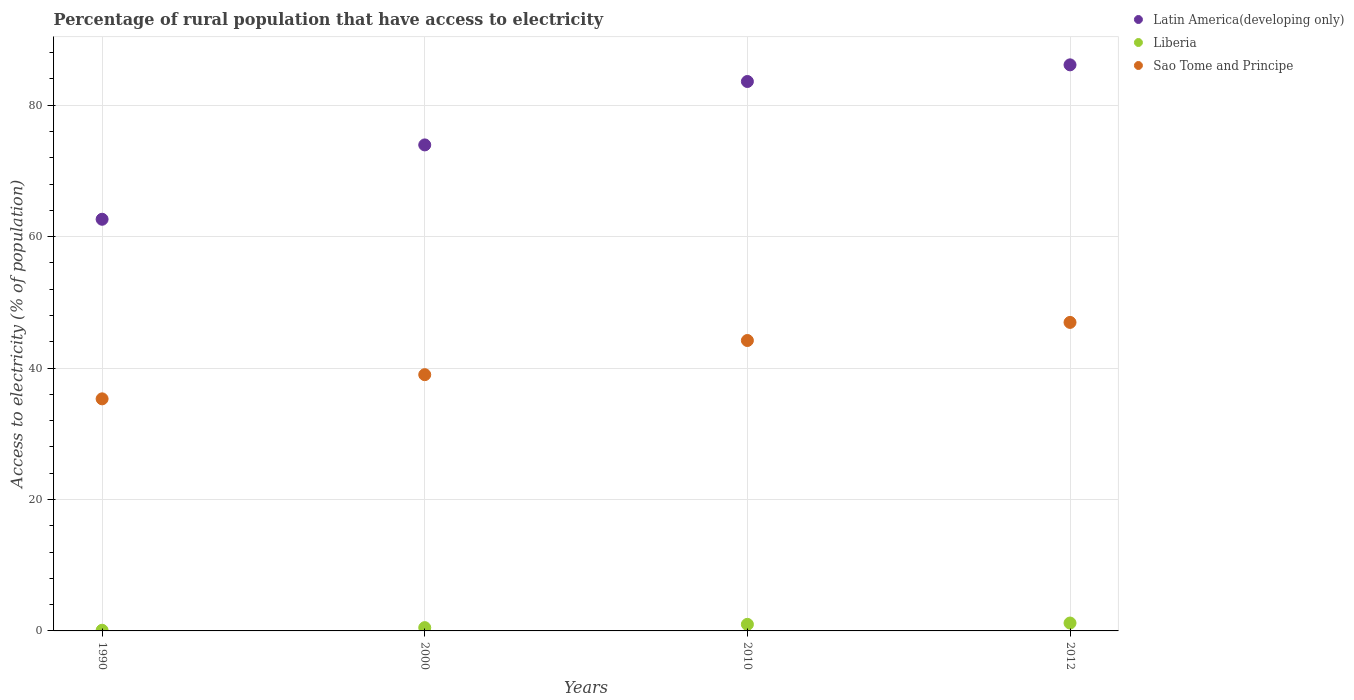How many different coloured dotlines are there?
Your response must be concise. 3. Is the number of dotlines equal to the number of legend labels?
Ensure brevity in your answer.  Yes. What is the percentage of rural population that have access to electricity in Sao Tome and Principe in 2000?
Keep it short and to the point. 39. Across all years, what is the maximum percentage of rural population that have access to electricity in Liberia?
Your response must be concise. 1.2. Across all years, what is the minimum percentage of rural population that have access to electricity in Latin America(developing only)?
Provide a succinct answer. 62.65. In which year was the percentage of rural population that have access to electricity in Sao Tome and Principe maximum?
Offer a very short reply. 2012. In which year was the percentage of rural population that have access to electricity in Liberia minimum?
Ensure brevity in your answer.  1990. What is the total percentage of rural population that have access to electricity in Sao Tome and Principe in the graph?
Ensure brevity in your answer.  165.47. What is the difference between the percentage of rural population that have access to electricity in Liberia in 2012 and the percentage of rural population that have access to electricity in Sao Tome and Principe in 2010?
Your answer should be compact. -43. What is the average percentage of rural population that have access to electricity in Latin America(developing only) per year?
Keep it short and to the point. 76.6. In the year 1990, what is the difference between the percentage of rural population that have access to electricity in Latin America(developing only) and percentage of rural population that have access to electricity in Liberia?
Offer a terse response. 62.55. What is the ratio of the percentage of rural population that have access to electricity in Latin America(developing only) in 1990 to that in 2000?
Ensure brevity in your answer.  0.85. Is the difference between the percentage of rural population that have access to electricity in Latin America(developing only) in 1990 and 2010 greater than the difference between the percentage of rural population that have access to electricity in Liberia in 1990 and 2010?
Make the answer very short. No. What is the difference between the highest and the second highest percentage of rural population that have access to electricity in Sao Tome and Principe?
Give a very brief answer. 2.75. What is the difference between the highest and the lowest percentage of rural population that have access to electricity in Latin America(developing only)?
Give a very brief answer. 23.5. In how many years, is the percentage of rural population that have access to electricity in Liberia greater than the average percentage of rural population that have access to electricity in Liberia taken over all years?
Offer a terse response. 2. Is the sum of the percentage of rural population that have access to electricity in Sao Tome and Principe in 1990 and 2012 greater than the maximum percentage of rural population that have access to electricity in Latin America(developing only) across all years?
Make the answer very short. No. Is it the case that in every year, the sum of the percentage of rural population that have access to electricity in Sao Tome and Principe and percentage of rural population that have access to electricity in Liberia  is greater than the percentage of rural population that have access to electricity in Latin America(developing only)?
Offer a very short reply. No. How many dotlines are there?
Your answer should be very brief. 3. What is the difference between two consecutive major ticks on the Y-axis?
Ensure brevity in your answer.  20. Does the graph contain any zero values?
Keep it short and to the point. No. How many legend labels are there?
Your response must be concise. 3. What is the title of the graph?
Make the answer very short. Percentage of rural population that have access to electricity. What is the label or title of the Y-axis?
Offer a terse response. Access to electricity (% of population). What is the Access to electricity (% of population) of Latin America(developing only) in 1990?
Offer a terse response. 62.65. What is the Access to electricity (% of population) of Sao Tome and Principe in 1990?
Offer a terse response. 35.32. What is the Access to electricity (% of population) of Latin America(developing only) in 2000?
Give a very brief answer. 73.97. What is the Access to electricity (% of population) of Latin America(developing only) in 2010?
Provide a succinct answer. 83.62. What is the Access to electricity (% of population) in Sao Tome and Principe in 2010?
Your answer should be very brief. 44.2. What is the Access to electricity (% of population) in Latin America(developing only) in 2012?
Make the answer very short. 86.15. What is the Access to electricity (% of population) of Sao Tome and Principe in 2012?
Provide a short and direct response. 46.95. Across all years, what is the maximum Access to electricity (% of population) in Latin America(developing only)?
Provide a short and direct response. 86.15. Across all years, what is the maximum Access to electricity (% of population) in Sao Tome and Principe?
Your answer should be compact. 46.95. Across all years, what is the minimum Access to electricity (% of population) in Latin America(developing only)?
Your answer should be very brief. 62.65. Across all years, what is the minimum Access to electricity (% of population) in Liberia?
Make the answer very short. 0.1. Across all years, what is the minimum Access to electricity (% of population) in Sao Tome and Principe?
Your response must be concise. 35.32. What is the total Access to electricity (% of population) in Latin America(developing only) in the graph?
Offer a terse response. 306.39. What is the total Access to electricity (% of population) of Liberia in the graph?
Offer a terse response. 2.8. What is the total Access to electricity (% of population) in Sao Tome and Principe in the graph?
Your answer should be very brief. 165.47. What is the difference between the Access to electricity (% of population) in Latin America(developing only) in 1990 and that in 2000?
Give a very brief answer. -11.32. What is the difference between the Access to electricity (% of population) in Liberia in 1990 and that in 2000?
Ensure brevity in your answer.  -0.4. What is the difference between the Access to electricity (% of population) of Sao Tome and Principe in 1990 and that in 2000?
Your answer should be very brief. -3.68. What is the difference between the Access to electricity (% of population) in Latin America(developing only) in 1990 and that in 2010?
Offer a terse response. -20.97. What is the difference between the Access to electricity (% of population) in Liberia in 1990 and that in 2010?
Make the answer very short. -0.9. What is the difference between the Access to electricity (% of population) of Sao Tome and Principe in 1990 and that in 2010?
Offer a very short reply. -8.88. What is the difference between the Access to electricity (% of population) in Latin America(developing only) in 1990 and that in 2012?
Give a very brief answer. -23.5. What is the difference between the Access to electricity (% of population) in Sao Tome and Principe in 1990 and that in 2012?
Give a very brief answer. -11.63. What is the difference between the Access to electricity (% of population) in Latin America(developing only) in 2000 and that in 2010?
Give a very brief answer. -9.65. What is the difference between the Access to electricity (% of population) in Liberia in 2000 and that in 2010?
Your answer should be very brief. -0.5. What is the difference between the Access to electricity (% of population) of Sao Tome and Principe in 2000 and that in 2010?
Your response must be concise. -5.2. What is the difference between the Access to electricity (% of population) in Latin America(developing only) in 2000 and that in 2012?
Provide a succinct answer. -12.19. What is the difference between the Access to electricity (% of population) in Sao Tome and Principe in 2000 and that in 2012?
Your answer should be very brief. -7.95. What is the difference between the Access to electricity (% of population) of Latin America(developing only) in 2010 and that in 2012?
Make the answer very short. -2.53. What is the difference between the Access to electricity (% of population) of Sao Tome and Principe in 2010 and that in 2012?
Make the answer very short. -2.75. What is the difference between the Access to electricity (% of population) of Latin America(developing only) in 1990 and the Access to electricity (% of population) of Liberia in 2000?
Ensure brevity in your answer.  62.15. What is the difference between the Access to electricity (% of population) of Latin America(developing only) in 1990 and the Access to electricity (% of population) of Sao Tome and Principe in 2000?
Your answer should be compact. 23.65. What is the difference between the Access to electricity (% of population) in Liberia in 1990 and the Access to electricity (% of population) in Sao Tome and Principe in 2000?
Provide a short and direct response. -38.9. What is the difference between the Access to electricity (% of population) in Latin America(developing only) in 1990 and the Access to electricity (% of population) in Liberia in 2010?
Offer a terse response. 61.65. What is the difference between the Access to electricity (% of population) of Latin America(developing only) in 1990 and the Access to electricity (% of population) of Sao Tome and Principe in 2010?
Your response must be concise. 18.45. What is the difference between the Access to electricity (% of population) of Liberia in 1990 and the Access to electricity (% of population) of Sao Tome and Principe in 2010?
Offer a very short reply. -44.1. What is the difference between the Access to electricity (% of population) of Latin America(developing only) in 1990 and the Access to electricity (% of population) of Liberia in 2012?
Your response must be concise. 61.45. What is the difference between the Access to electricity (% of population) in Latin America(developing only) in 1990 and the Access to electricity (% of population) in Sao Tome and Principe in 2012?
Make the answer very short. 15.7. What is the difference between the Access to electricity (% of population) in Liberia in 1990 and the Access to electricity (% of population) in Sao Tome and Principe in 2012?
Offer a very short reply. -46.85. What is the difference between the Access to electricity (% of population) of Latin America(developing only) in 2000 and the Access to electricity (% of population) of Liberia in 2010?
Offer a very short reply. 72.97. What is the difference between the Access to electricity (% of population) of Latin America(developing only) in 2000 and the Access to electricity (% of population) of Sao Tome and Principe in 2010?
Your answer should be compact. 29.77. What is the difference between the Access to electricity (% of population) of Liberia in 2000 and the Access to electricity (% of population) of Sao Tome and Principe in 2010?
Offer a terse response. -43.7. What is the difference between the Access to electricity (% of population) of Latin America(developing only) in 2000 and the Access to electricity (% of population) of Liberia in 2012?
Provide a short and direct response. 72.77. What is the difference between the Access to electricity (% of population) in Latin America(developing only) in 2000 and the Access to electricity (% of population) in Sao Tome and Principe in 2012?
Keep it short and to the point. 27.01. What is the difference between the Access to electricity (% of population) in Liberia in 2000 and the Access to electricity (% of population) in Sao Tome and Principe in 2012?
Give a very brief answer. -46.45. What is the difference between the Access to electricity (% of population) in Latin America(developing only) in 2010 and the Access to electricity (% of population) in Liberia in 2012?
Ensure brevity in your answer.  82.42. What is the difference between the Access to electricity (% of population) of Latin America(developing only) in 2010 and the Access to electricity (% of population) of Sao Tome and Principe in 2012?
Provide a succinct answer. 36.66. What is the difference between the Access to electricity (% of population) in Liberia in 2010 and the Access to electricity (% of population) in Sao Tome and Principe in 2012?
Offer a terse response. -45.95. What is the average Access to electricity (% of population) in Latin America(developing only) per year?
Ensure brevity in your answer.  76.6. What is the average Access to electricity (% of population) in Sao Tome and Principe per year?
Offer a very short reply. 41.37. In the year 1990, what is the difference between the Access to electricity (% of population) of Latin America(developing only) and Access to electricity (% of population) of Liberia?
Offer a very short reply. 62.55. In the year 1990, what is the difference between the Access to electricity (% of population) in Latin America(developing only) and Access to electricity (% of population) in Sao Tome and Principe?
Offer a very short reply. 27.33. In the year 1990, what is the difference between the Access to electricity (% of population) of Liberia and Access to electricity (% of population) of Sao Tome and Principe?
Your response must be concise. -35.22. In the year 2000, what is the difference between the Access to electricity (% of population) of Latin America(developing only) and Access to electricity (% of population) of Liberia?
Provide a short and direct response. 73.47. In the year 2000, what is the difference between the Access to electricity (% of population) of Latin America(developing only) and Access to electricity (% of population) of Sao Tome and Principe?
Offer a terse response. 34.97. In the year 2000, what is the difference between the Access to electricity (% of population) in Liberia and Access to electricity (% of population) in Sao Tome and Principe?
Provide a short and direct response. -38.5. In the year 2010, what is the difference between the Access to electricity (% of population) in Latin America(developing only) and Access to electricity (% of population) in Liberia?
Give a very brief answer. 82.62. In the year 2010, what is the difference between the Access to electricity (% of population) of Latin America(developing only) and Access to electricity (% of population) of Sao Tome and Principe?
Offer a terse response. 39.42. In the year 2010, what is the difference between the Access to electricity (% of population) in Liberia and Access to electricity (% of population) in Sao Tome and Principe?
Provide a short and direct response. -43.2. In the year 2012, what is the difference between the Access to electricity (% of population) in Latin America(developing only) and Access to electricity (% of population) in Liberia?
Offer a terse response. 84.95. In the year 2012, what is the difference between the Access to electricity (% of population) in Latin America(developing only) and Access to electricity (% of population) in Sao Tome and Principe?
Offer a terse response. 39.2. In the year 2012, what is the difference between the Access to electricity (% of population) of Liberia and Access to electricity (% of population) of Sao Tome and Principe?
Your answer should be very brief. -45.75. What is the ratio of the Access to electricity (% of population) in Latin America(developing only) in 1990 to that in 2000?
Provide a short and direct response. 0.85. What is the ratio of the Access to electricity (% of population) of Liberia in 1990 to that in 2000?
Your answer should be very brief. 0.2. What is the ratio of the Access to electricity (% of population) of Sao Tome and Principe in 1990 to that in 2000?
Your answer should be compact. 0.91. What is the ratio of the Access to electricity (% of population) of Latin America(developing only) in 1990 to that in 2010?
Offer a very short reply. 0.75. What is the ratio of the Access to electricity (% of population) of Sao Tome and Principe in 1990 to that in 2010?
Your answer should be compact. 0.8. What is the ratio of the Access to electricity (% of population) of Latin America(developing only) in 1990 to that in 2012?
Your answer should be compact. 0.73. What is the ratio of the Access to electricity (% of population) of Liberia in 1990 to that in 2012?
Make the answer very short. 0.08. What is the ratio of the Access to electricity (% of population) of Sao Tome and Principe in 1990 to that in 2012?
Your answer should be very brief. 0.75. What is the ratio of the Access to electricity (% of population) in Latin America(developing only) in 2000 to that in 2010?
Give a very brief answer. 0.88. What is the ratio of the Access to electricity (% of population) of Sao Tome and Principe in 2000 to that in 2010?
Offer a terse response. 0.88. What is the ratio of the Access to electricity (% of population) in Latin America(developing only) in 2000 to that in 2012?
Provide a short and direct response. 0.86. What is the ratio of the Access to electricity (% of population) in Liberia in 2000 to that in 2012?
Provide a short and direct response. 0.42. What is the ratio of the Access to electricity (% of population) in Sao Tome and Principe in 2000 to that in 2012?
Your response must be concise. 0.83. What is the ratio of the Access to electricity (% of population) of Latin America(developing only) in 2010 to that in 2012?
Your response must be concise. 0.97. What is the ratio of the Access to electricity (% of population) of Sao Tome and Principe in 2010 to that in 2012?
Make the answer very short. 0.94. What is the difference between the highest and the second highest Access to electricity (% of population) in Latin America(developing only)?
Ensure brevity in your answer.  2.53. What is the difference between the highest and the second highest Access to electricity (% of population) of Sao Tome and Principe?
Make the answer very short. 2.75. What is the difference between the highest and the lowest Access to electricity (% of population) of Latin America(developing only)?
Your response must be concise. 23.5. What is the difference between the highest and the lowest Access to electricity (% of population) in Sao Tome and Principe?
Your answer should be compact. 11.63. 